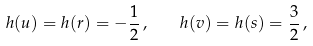<formula> <loc_0><loc_0><loc_500><loc_500>h ( u ) = h ( r ) = - \frac { 1 } { 2 } \, , \quad h ( v ) = h ( s ) = \frac { 3 } { 2 } \, ,</formula> 